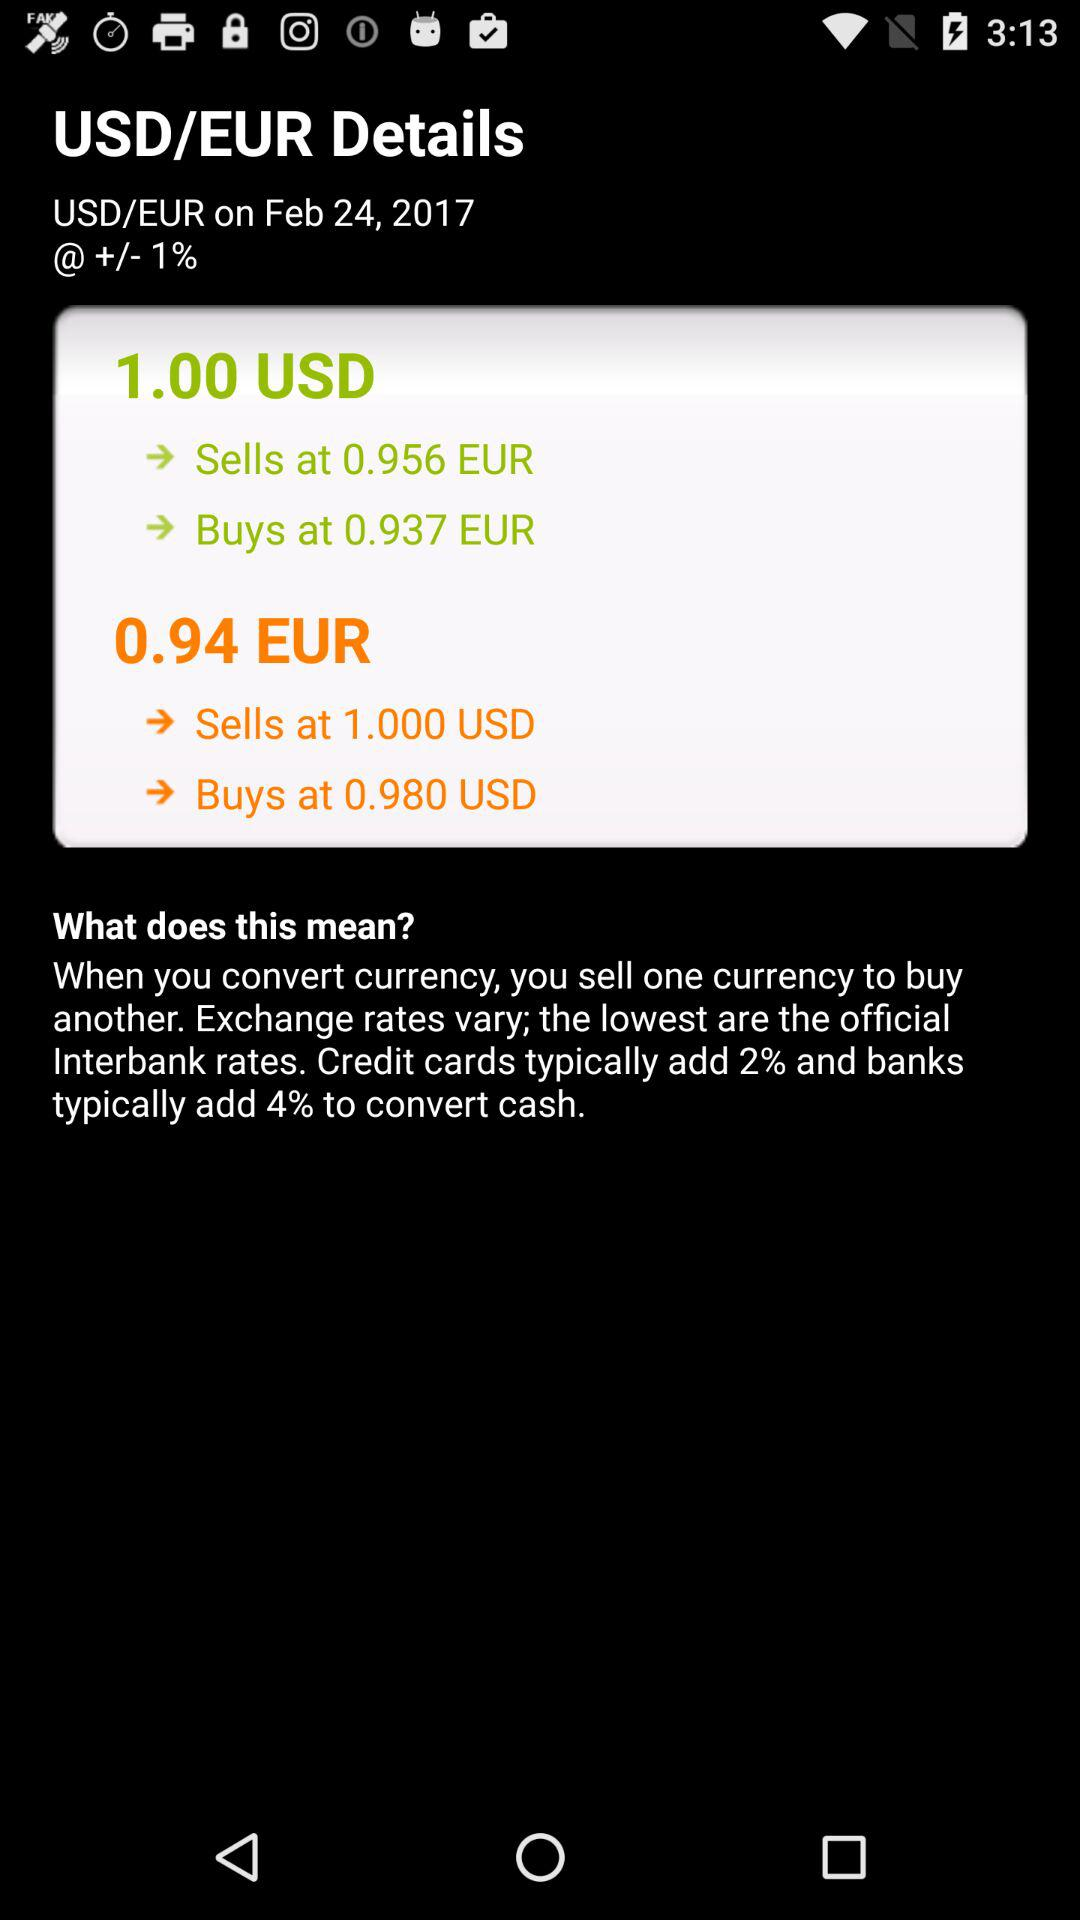What is the buying price of the USD against 0.94 euro? The buying price of the USD against 0.94 euro is 0.980. 